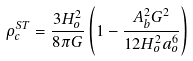<formula> <loc_0><loc_0><loc_500><loc_500>\rho _ { c } ^ { S T } = \frac { 3 H _ { o } ^ { 2 } } { 8 \pi G } \left ( 1 - \frac { A _ { b } ^ { 2 } G ^ { 2 } } { 1 2 H _ { o } ^ { 2 } a _ { o } ^ { 6 } } \right )</formula> 